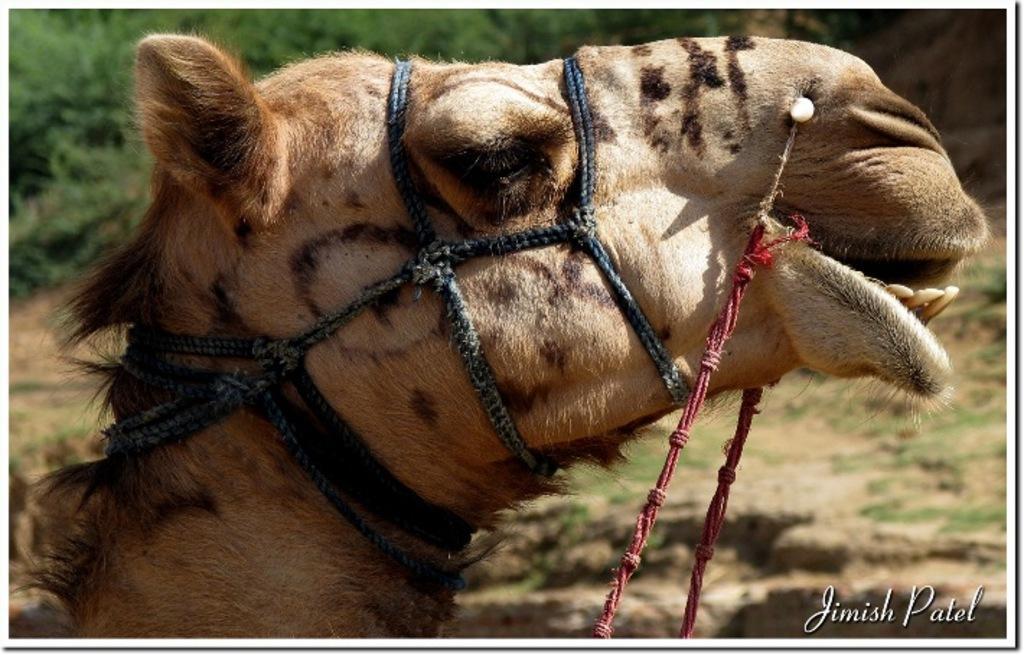How would you summarize this image in a sentence or two? In this picture we can see camel's face. In the background we can see trees. On the bottom right corner there is a watermark. Here we can see ropes. 